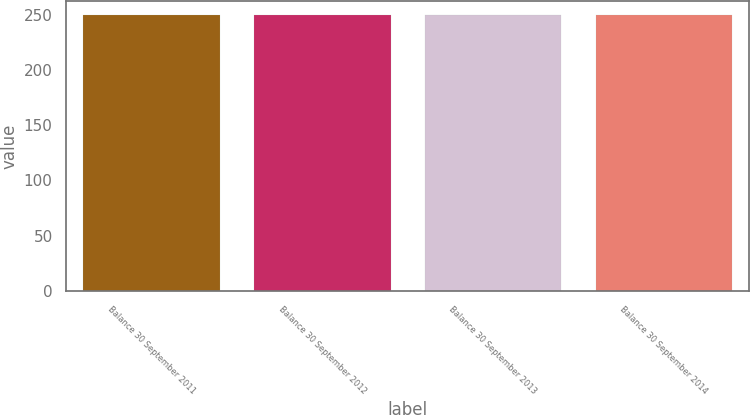Convert chart. <chart><loc_0><loc_0><loc_500><loc_500><bar_chart><fcel>Balance 30 September 2011<fcel>Balance 30 September 2012<fcel>Balance 30 September 2013<fcel>Balance 30 September 2014<nl><fcel>249.4<fcel>249.5<fcel>249.6<fcel>249.7<nl></chart> 